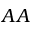Convert formula to latex. <formula><loc_0><loc_0><loc_500><loc_500>A A</formula> 